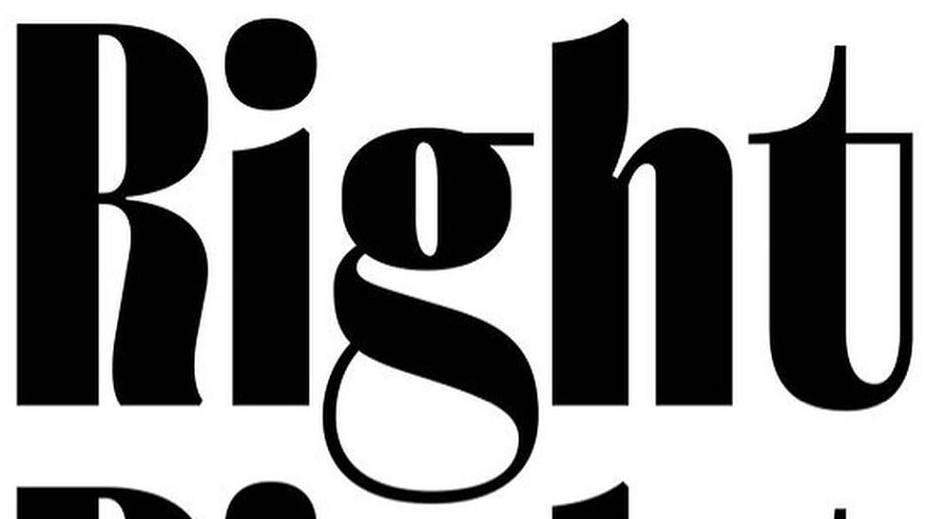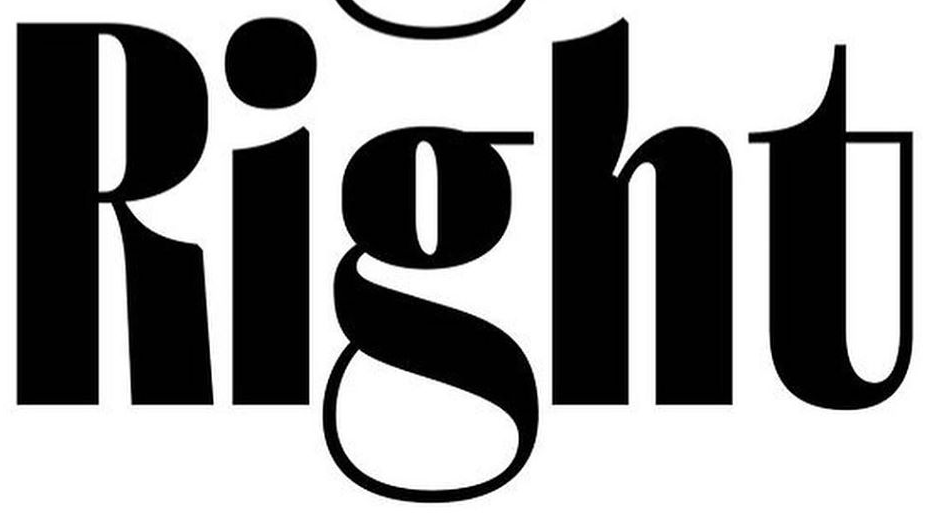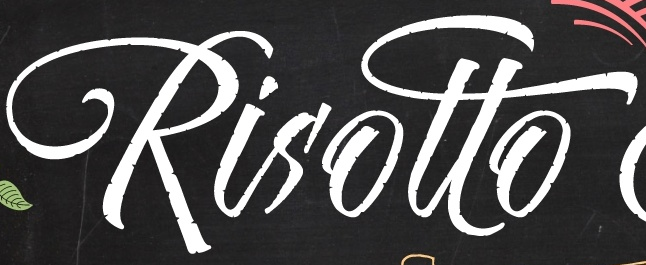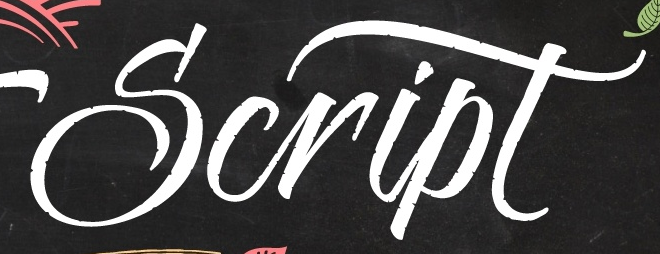Identify the words shown in these images in order, separated by a semicolon. Right; Right; Risotto; Script 